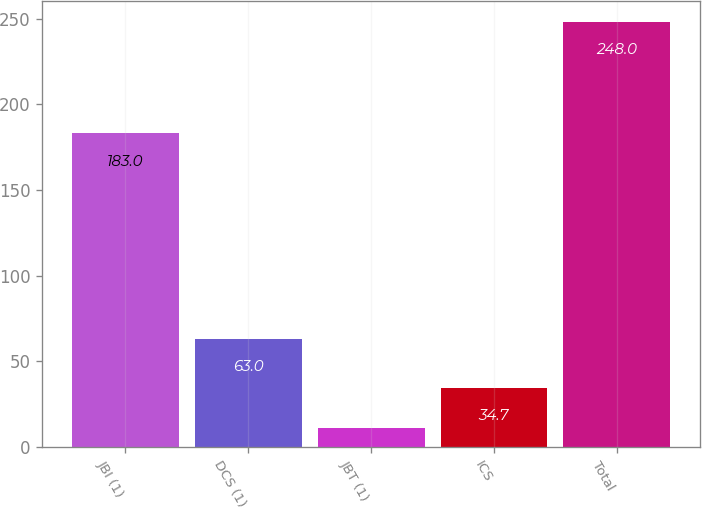Convert chart. <chart><loc_0><loc_0><loc_500><loc_500><bar_chart><fcel>JBI (1)<fcel>DCS (1)<fcel>JBT (1)<fcel>ICS<fcel>Total<nl><fcel>183<fcel>63<fcel>11<fcel>34.7<fcel>248<nl></chart> 